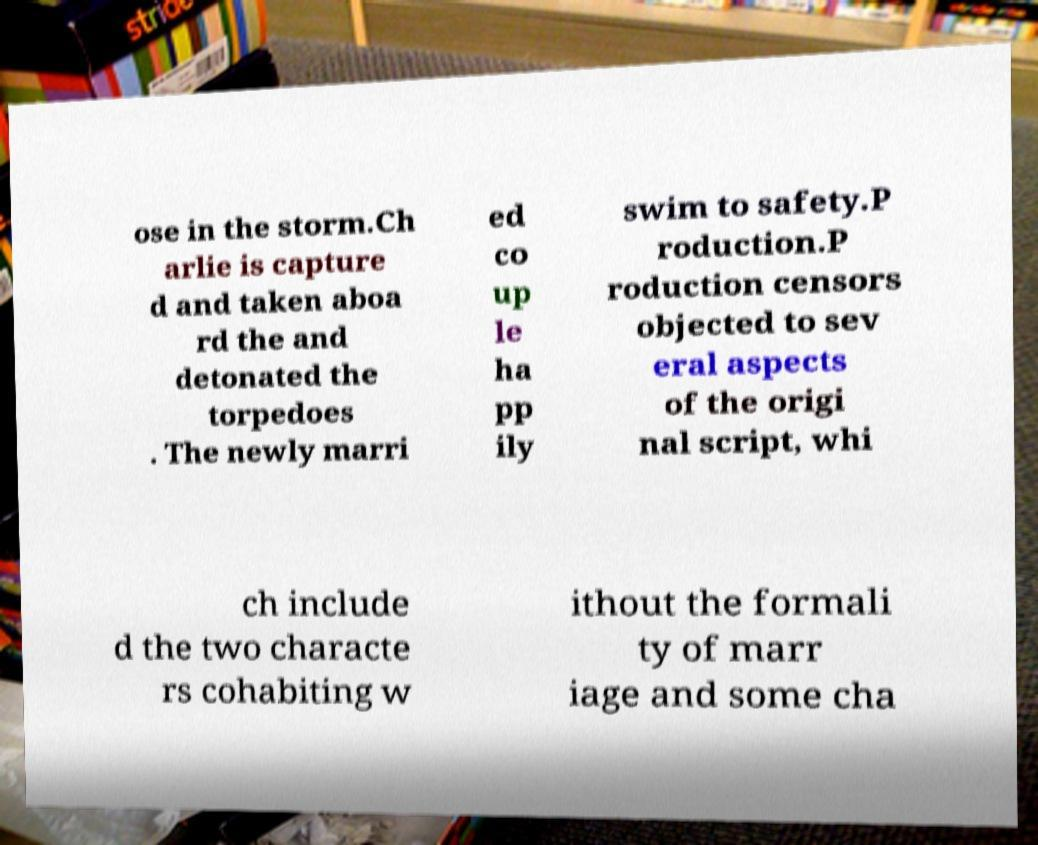Could you extract and type out the text from this image? ose in the storm.Ch arlie is capture d and taken aboa rd the and detonated the torpedoes . The newly marri ed co up le ha pp ily swim to safety.P roduction.P roduction censors objected to sev eral aspects of the origi nal script, whi ch include d the two characte rs cohabiting w ithout the formali ty of marr iage and some cha 